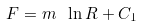<formula> <loc_0><loc_0><loc_500><loc_500>F = m \ \ln R + C _ { 1 }</formula> 